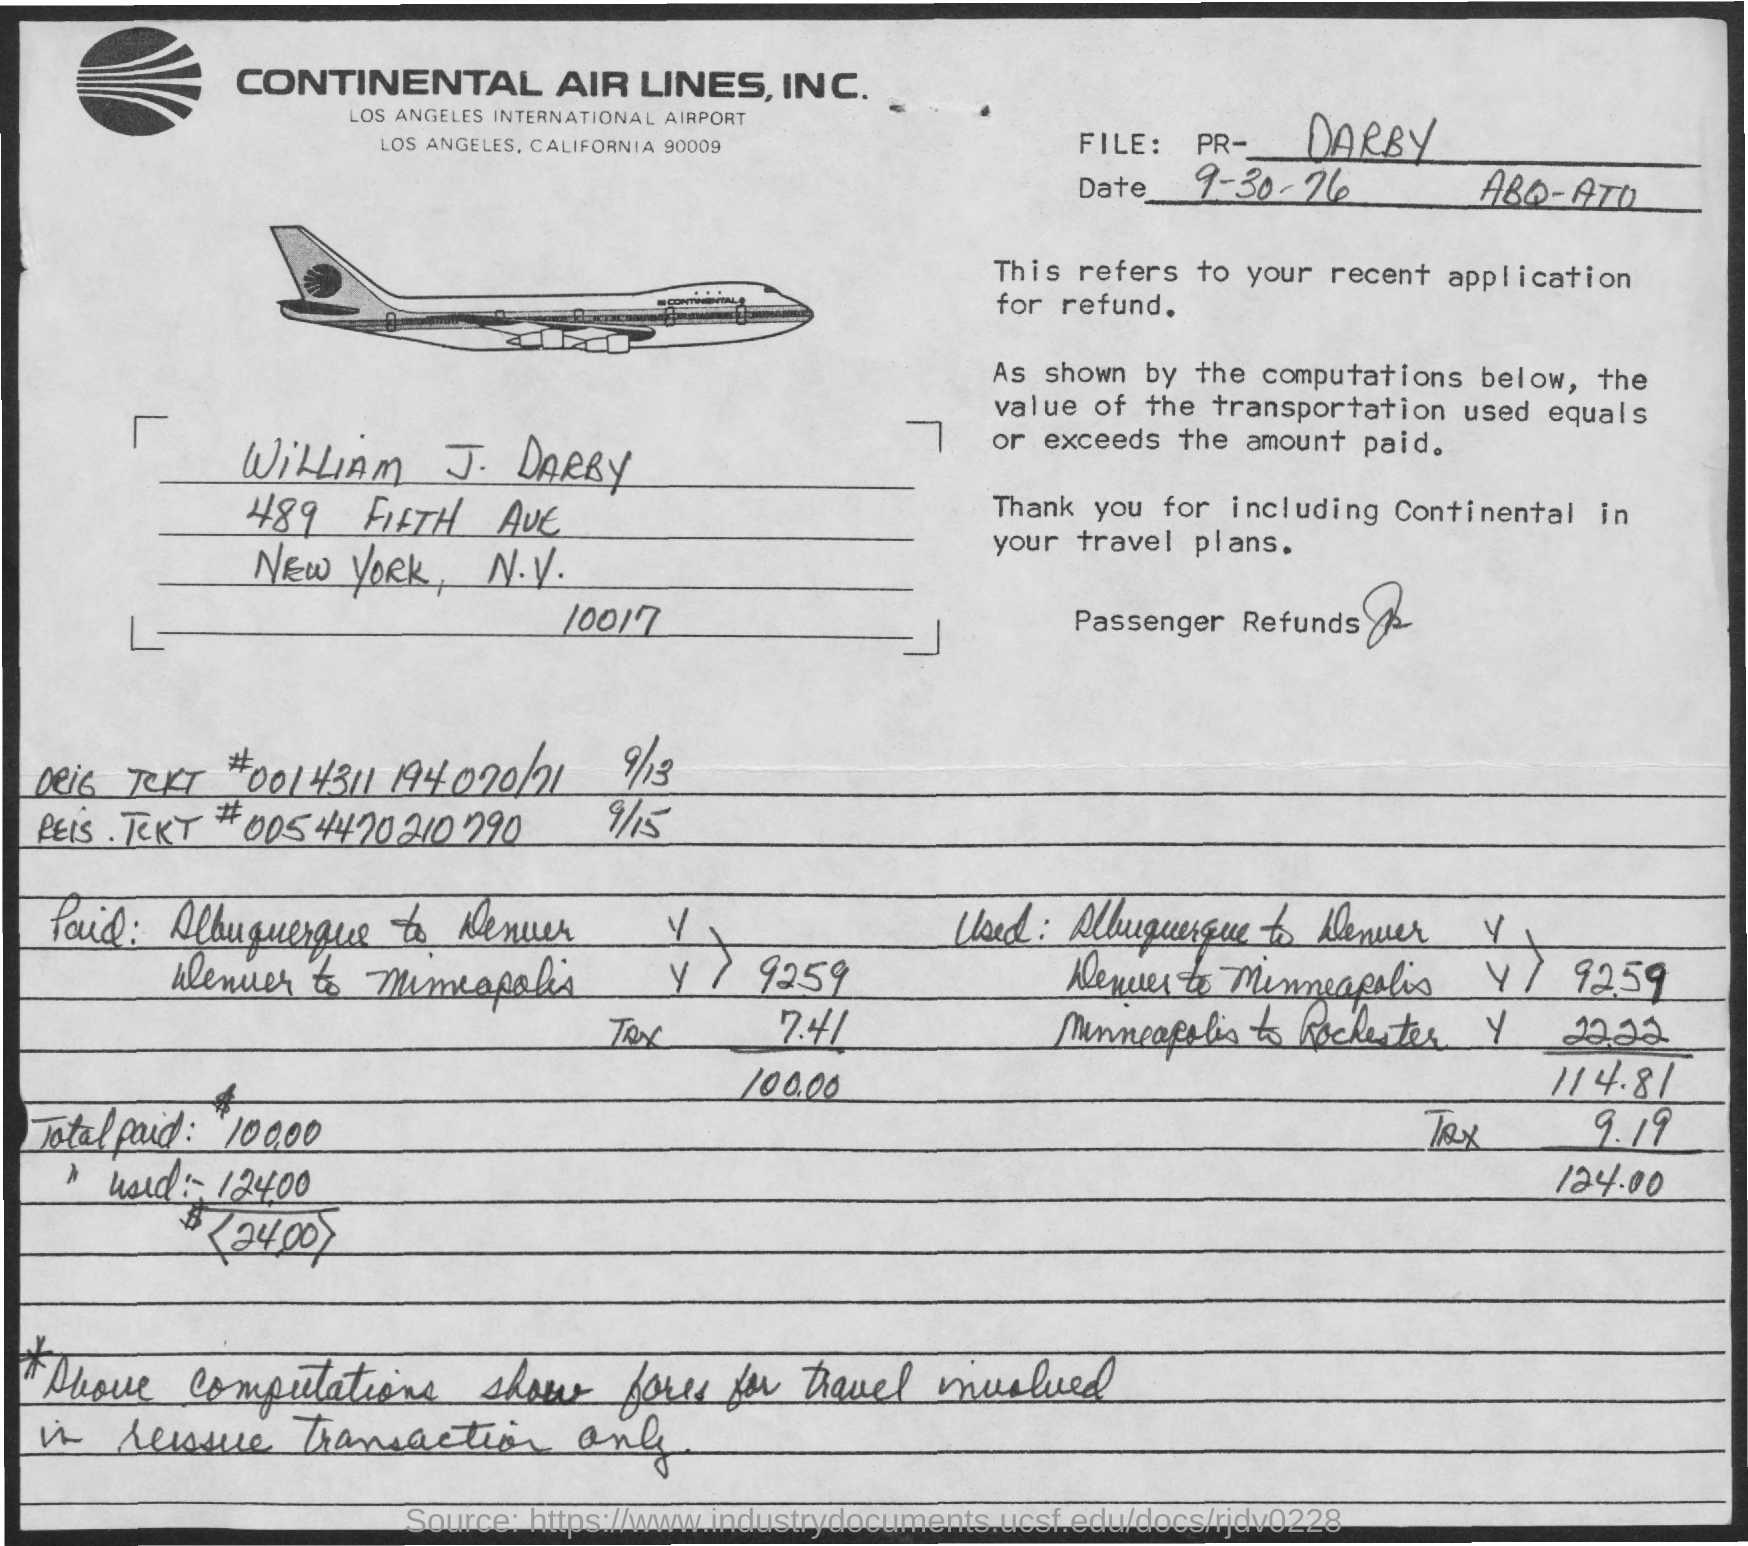What is the name of the person?
Your answer should be very brief. William j. darby. What is the total amount paid?
Your answer should be very brief. 100. What is the date mentioned in the document?
Your response must be concise. 9-30-76. 